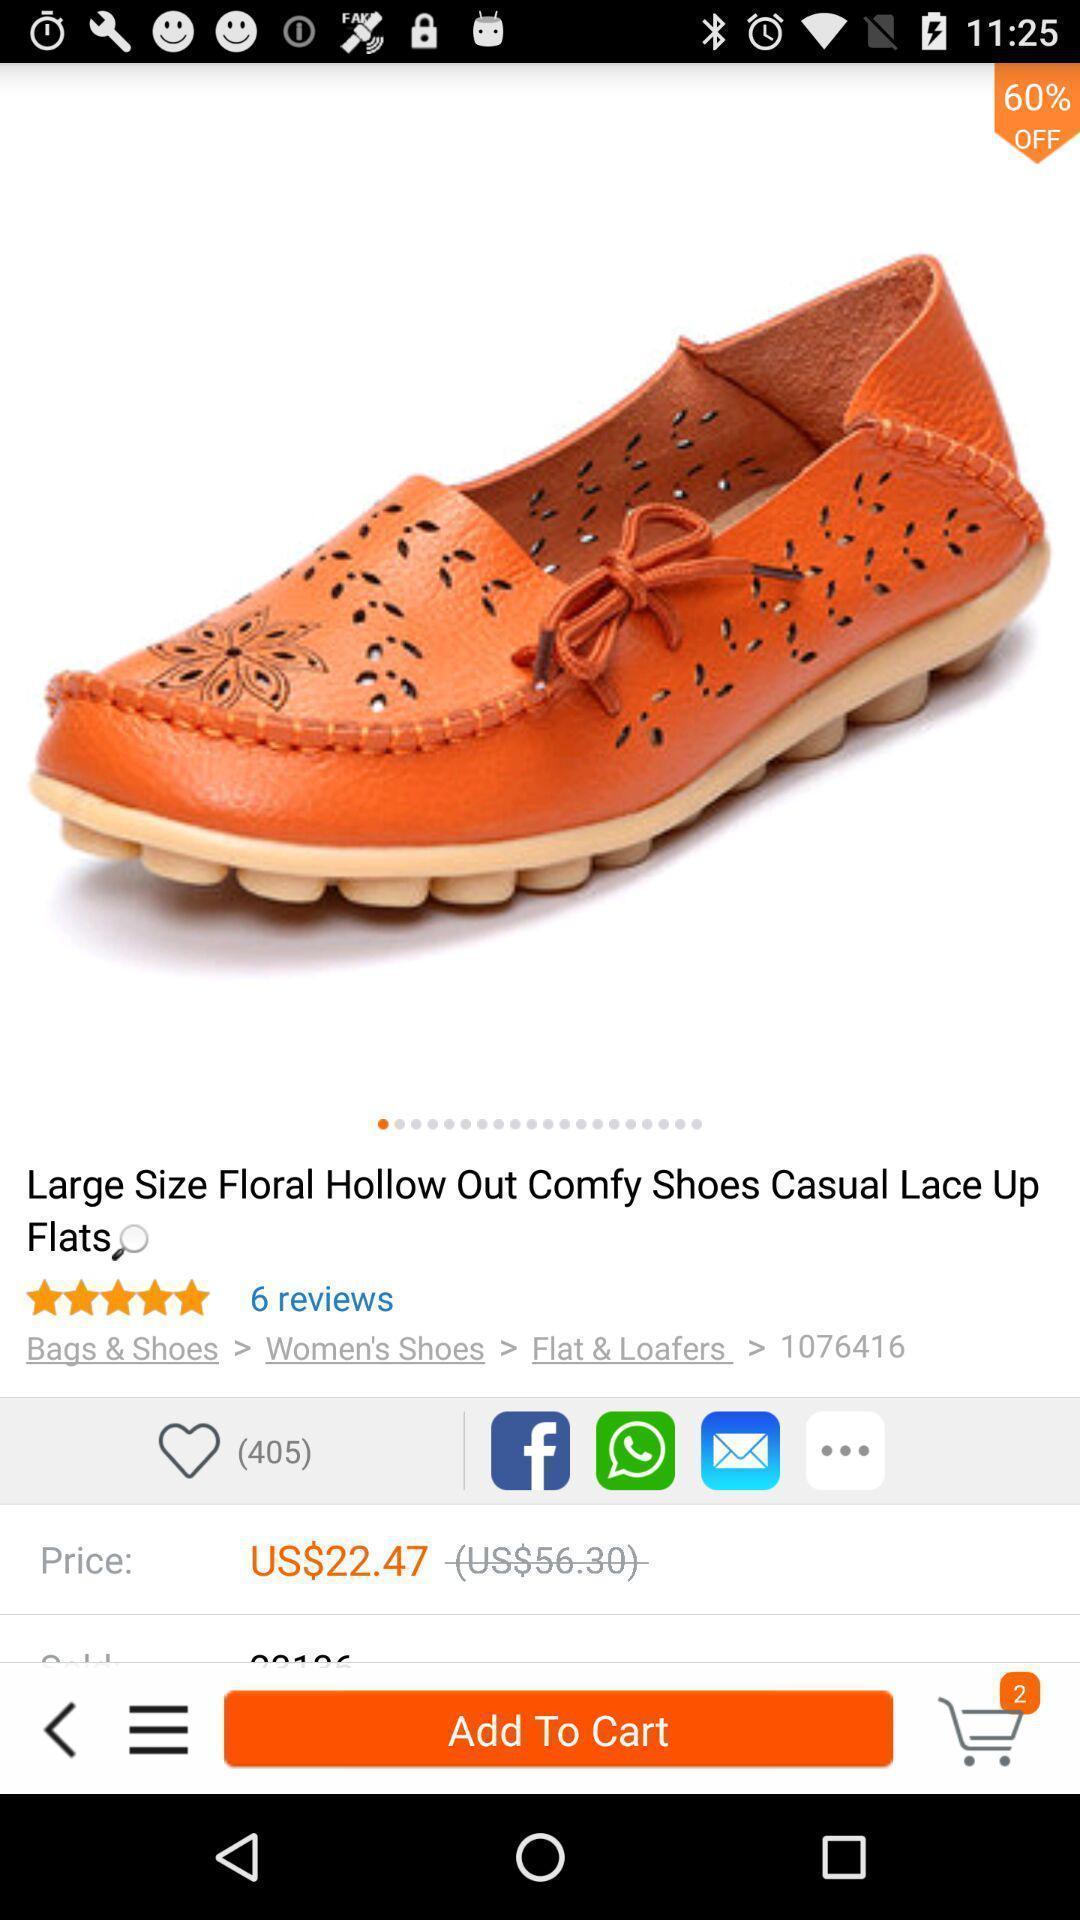Describe the visual elements of this screenshot. Shopping item with its description is displaying. 